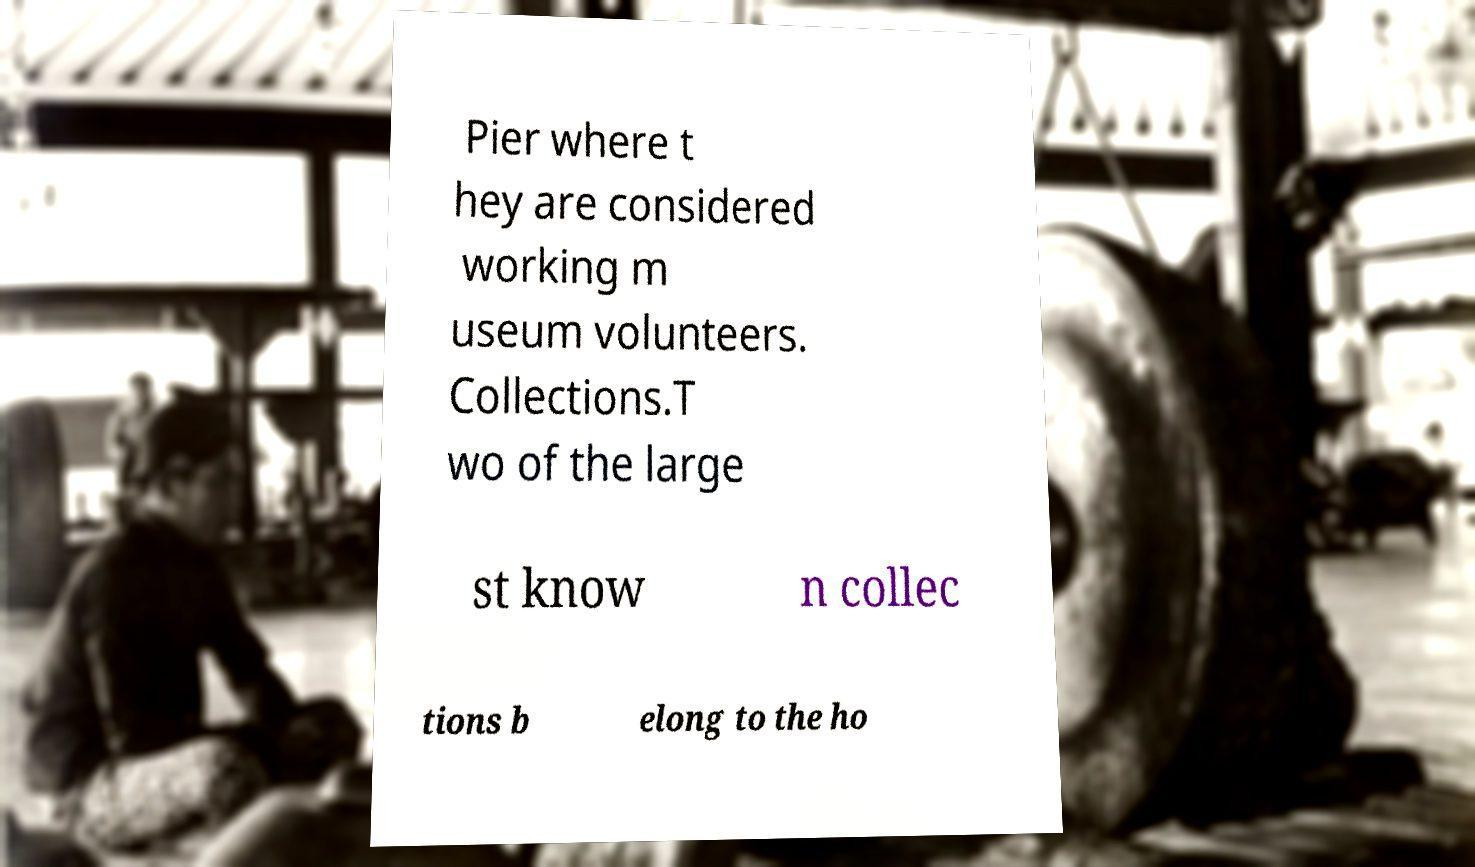I need the written content from this picture converted into text. Can you do that? Pier where t hey are considered working m useum volunteers. Collections.T wo of the large st know n collec tions b elong to the ho 